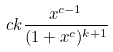Convert formula to latex. <formula><loc_0><loc_0><loc_500><loc_500>c k \frac { x ^ { c - 1 } } { ( 1 + x ^ { c } ) ^ { k + 1 } }</formula> 